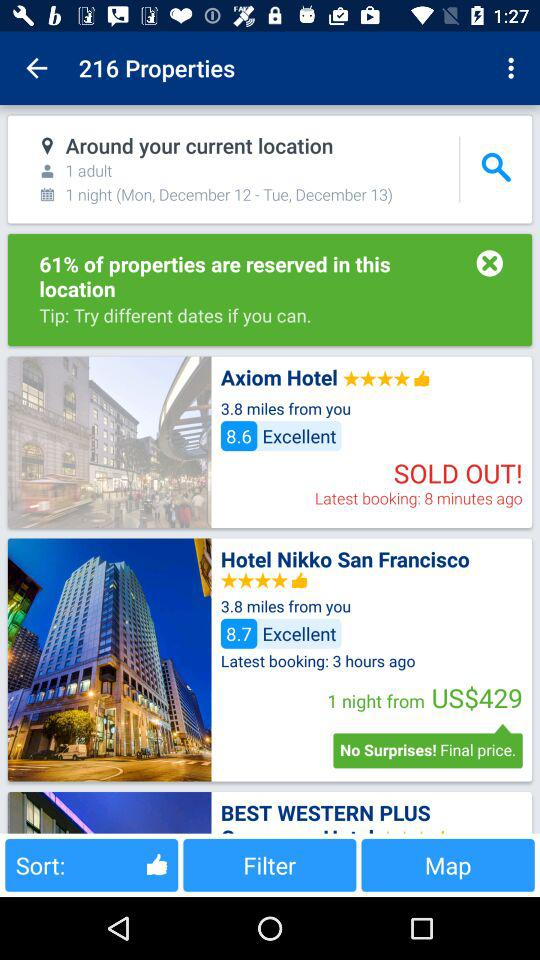What is the starting price of the Hotel Nikko San Francisco for one night? The price is $429 USD. 